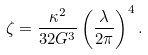Convert formula to latex. <formula><loc_0><loc_0><loc_500><loc_500>\zeta = \frac { \kappa ^ { 2 } } { 3 2 G ^ { 3 } } \left ( \frac { \lambda } { 2 \pi } \right ) ^ { 4 } .</formula> 